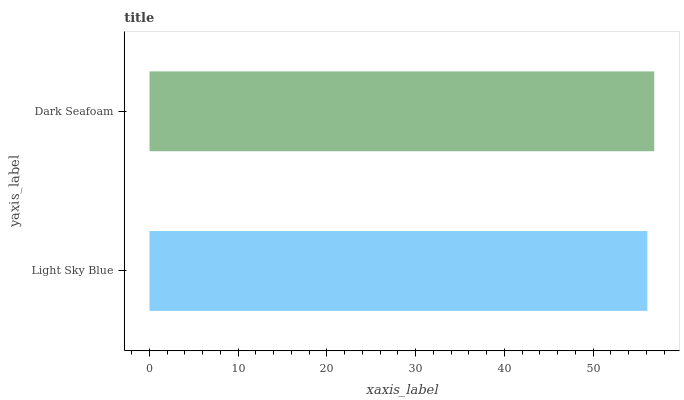Is Light Sky Blue the minimum?
Answer yes or no. Yes. Is Dark Seafoam the maximum?
Answer yes or no. Yes. Is Dark Seafoam the minimum?
Answer yes or no. No. Is Dark Seafoam greater than Light Sky Blue?
Answer yes or no. Yes. Is Light Sky Blue less than Dark Seafoam?
Answer yes or no. Yes. Is Light Sky Blue greater than Dark Seafoam?
Answer yes or no. No. Is Dark Seafoam less than Light Sky Blue?
Answer yes or no. No. Is Dark Seafoam the high median?
Answer yes or no. Yes. Is Light Sky Blue the low median?
Answer yes or no. Yes. Is Light Sky Blue the high median?
Answer yes or no. No. Is Dark Seafoam the low median?
Answer yes or no. No. 